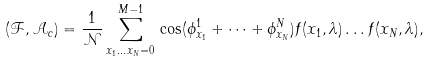Convert formula to latex. <formula><loc_0><loc_0><loc_500><loc_500>( \mathcal { F } , \mathcal { A } _ { c } ) = \frac { 1 } { \mathcal { N } } \sum _ { x _ { 1 } \dots x _ { N } = 0 } ^ { M - 1 } \, \cos ( \phi _ { x _ { 1 } } ^ { 1 } + \dots + \phi _ { x _ { N } } ^ { N } ) f ( x _ { 1 } , \lambda ) \dots f ( x _ { N } , \lambda ) ,</formula> 